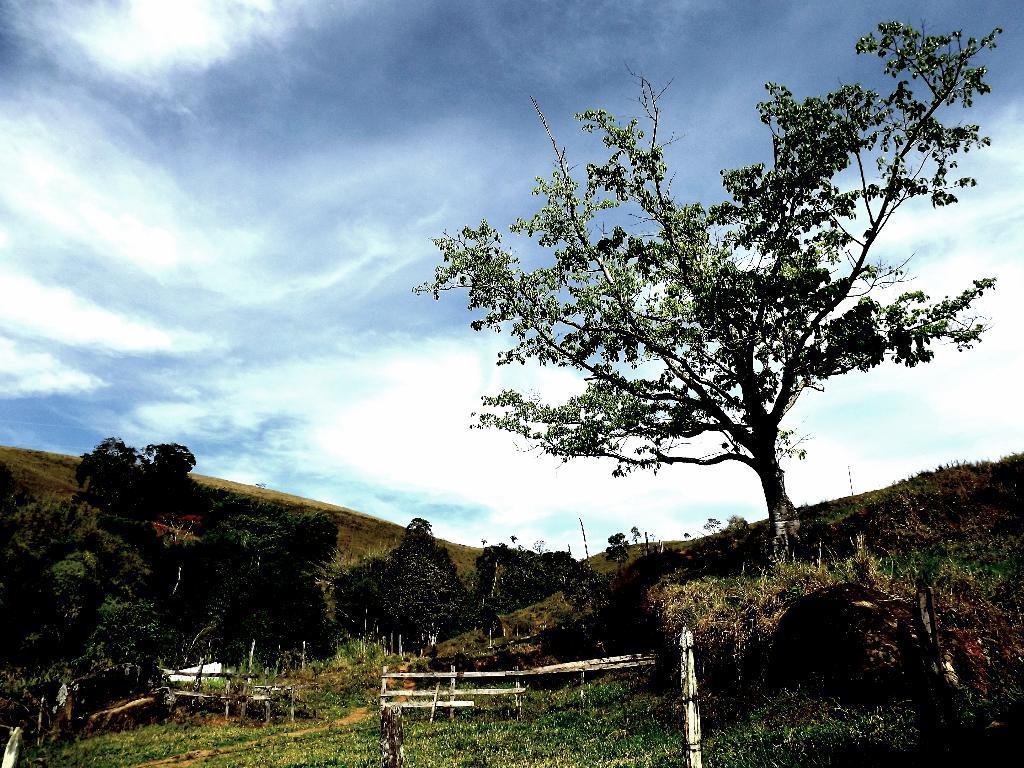In one or two sentences, can you explain what this image depicts? In this picture we can see trees and wooden objects on the ground and in the background we can see sky with clouds. 